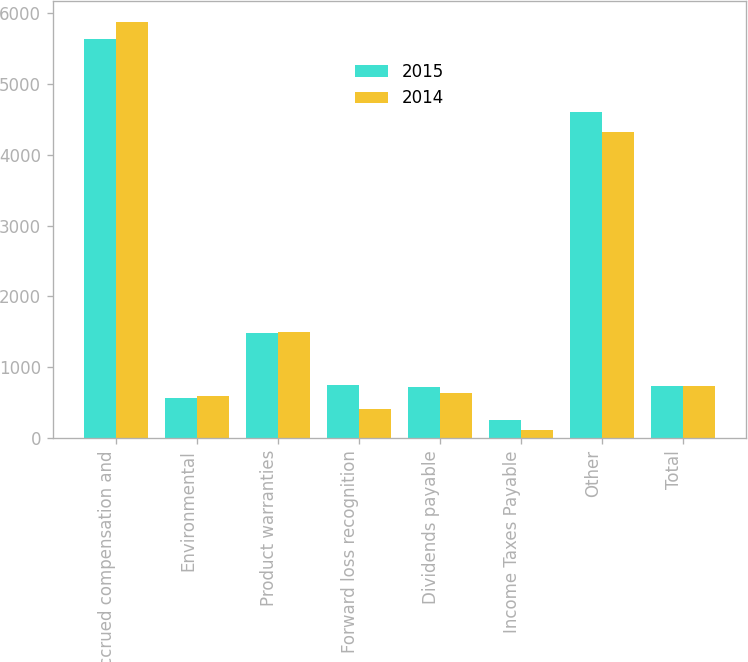Convert chart to OTSL. <chart><loc_0><loc_0><loc_500><loc_500><stacked_bar_chart><ecel><fcel>Accrued compensation and<fcel>Environmental<fcel>Product warranties<fcel>Forward loss recognition<fcel>Dividends payable<fcel>Income Taxes Payable<fcel>Other<fcel>Total<nl><fcel>2015<fcel>5624<fcel>566<fcel>1485<fcel>757<fcel>721<fcel>262<fcel>4599<fcel>739<nl><fcel>2014<fcel>5868<fcel>601<fcel>1504<fcel>414<fcel>637<fcel>119<fcel>4319<fcel>739<nl></chart> 